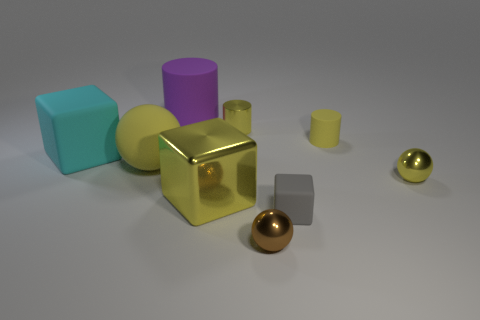Is there any other thing that has the same size as the metallic block?
Your answer should be compact. Yes. There is a rubber cube that is in front of the tiny yellow metallic object on the right side of the gray block; what is its size?
Give a very brief answer. Small. The big matte sphere has what color?
Make the answer very short. Yellow. What number of rubber things are to the right of the yellow sphere that is to the left of the yellow rubber cylinder?
Ensure brevity in your answer.  3. There is a tiny yellow metal object that is behind the small yellow ball; are there any tiny rubber cylinders that are left of it?
Offer a very short reply. No. There is a purple cylinder; are there any tiny brown metal balls on the right side of it?
Give a very brief answer. Yes. Does the small yellow shiny thing that is in front of the cyan rubber object have the same shape as the large yellow rubber thing?
Offer a very short reply. Yes. What number of green things have the same shape as the small yellow matte thing?
Your answer should be compact. 0. Are there any things that have the same material as the large purple cylinder?
Provide a short and direct response. Yes. What is the material of the yellow cylinder that is behind the rubber cylinder in front of the big purple thing?
Your answer should be very brief. Metal. 